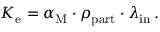<formula> <loc_0><loc_0><loc_500><loc_500>\begin{array} { r } { K _ { e } = \alpha _ { M } \cdot \rho _ { p a r t } \cdot \lambda _ { i n } \, . } \end{array}</formula> 